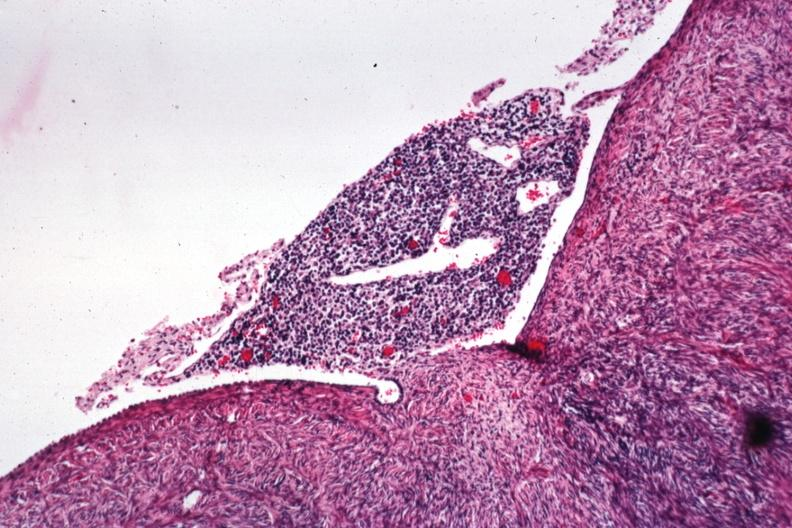s left ventricle hypertrophy present?
Answer the question using a single word or phrase. No 